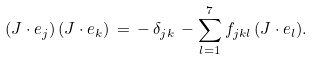<formula> <loc_0><loc_0><loc_500><loc_500>( J \cdot { e } _ { j } ) \, ( J \cdot { e } _ { k } ) \, = \, - \, \delta _ { j k } \, - \sum _ { l = 1 } ^ { 7 } f _ { j k l } \, ( J \cdot { e } _ { l } ) .</formula> 